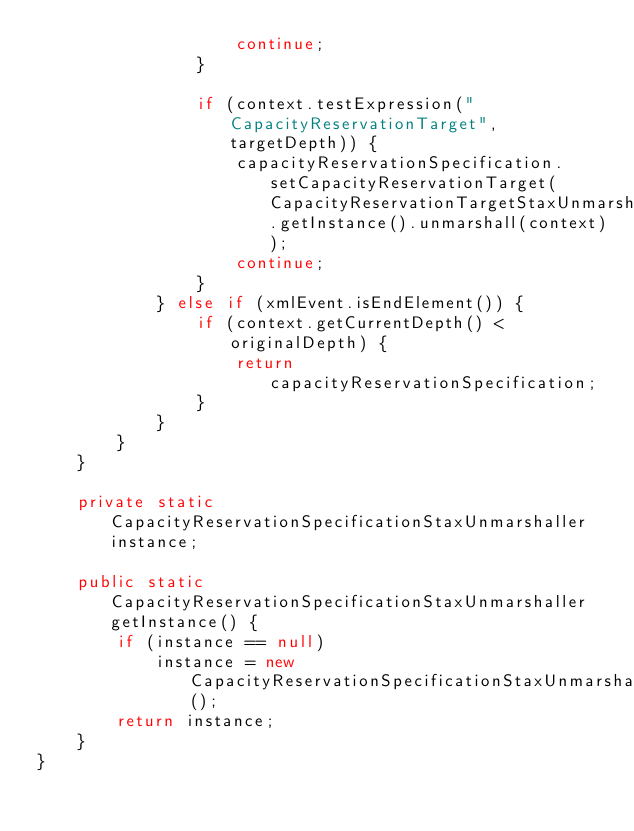Convert code to text. <code><loc_0><loc_0><loc_500><loc_500><_Java_>                    continue;
                }

                if (context.testExpression("CapacityReservationTarget", targetDepth)) {
                    capacityReservationSpecification.setCapacityReservationTarget(CapacityReservationTargetStaxUnmarshaller.getInstance().unmarshall(context));
                    continue;
                }
            } else if (xmlEvent.isEndElement()) {
                if (context.getCurrentDepth() < originalDepth) {
                    return capacityReservationSpecification;
                }
            }
        }
    }

    private static CapacityReservationSpecificationStaxUnmarshaller instance;

    public static CapacityReservationSpecificationStaxUnmarshaller getInstance() {
        if (instance == null)
            instance = new CapacityReservationSpecificationStaxUnmarshaller();
        return instance;
    }
}
</code> 